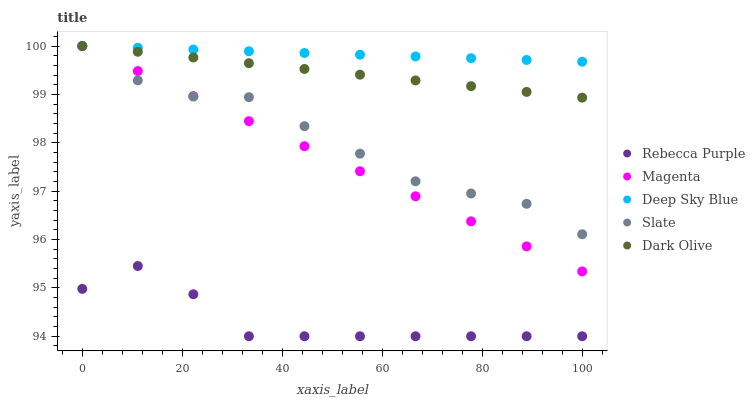Does Rebecca Purple have the minimum area under the curve?
Answer yes or no. Yes. Does Deep Sky Blue have the maximum area under the curve?
Answer yes or no. Yes. Does Magenta have the minimum area under the curve?
Answer yes or no. No. Does Magenta have the maximum area under the curve?
Answer yes or no. No. Is Deep Sky Blue the smoothest?
Answer yes or no. Yes. Is Rebecca Purple the roughest?
Answer yes or no. Yes. Is Magenta the smoothest?
Answer yes or no. No. Is Magenta the roughest?
Answer yes or no. No. Does Rebecca Purple have the lowest value?
Answer yes or no. Yes. Does Magenta have the lowest value?
Answer yes or no. No. Does Deep Sky Blue have the highest value?
Answer yes or no. Yes. Does Rebecca Purple have the highest value?
Answer yes or no. No. Is Rebecca Purple less than Deep Sky Blue?
Answer yes or no. Yes. Is Magenta greater than Rebecca Purple?
Answer yes or no. Yes. Does Magenta intersect Deep Sky Blue?
Answer yes or no. Yes. Is Magenta less than Deep Sky Blue?
Answer yes or no. No. Is Magenta greater than Deep Sky Blue?
Answer yes or no. No. Does Rebecca Purple intersect Deep Sky Blue?
Answer yes or no. No. 